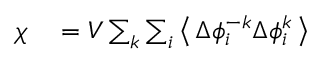Convert formula to latex. <formula><loc_0><loc_0><loc_500><loc_500>\begin{array} { r l } { \chi } & = V \sum _ { k } \sum _ { i } \left \langle \, \Delta \phi _ { i } ^ { - k } \Delta \phi _ { i } ^ { k } \, \right \rangle } \end{array}</formula> 